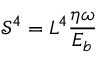Convert formula to latex. <formula><loc_0><loc_0><loc_500><loc_500>\mathcal { S } ^ { 4 } = L ^ { 4 } \frac { \eta \omega } { E _ { b } }</formula> 